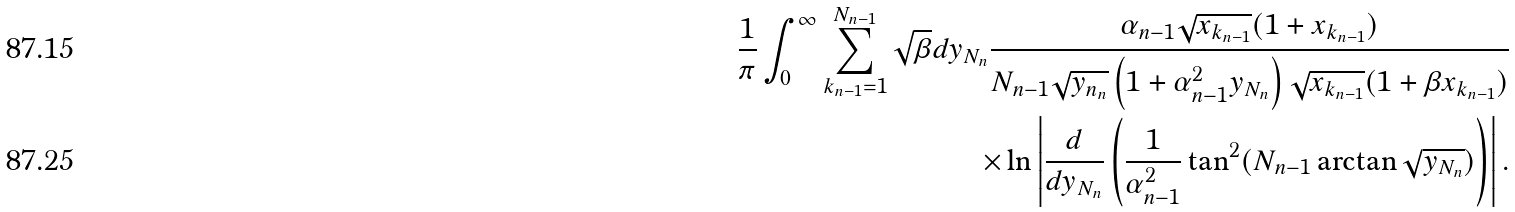<formula> <loc_0><loc_0><loc_500><loc_500>\frac { 1 } { \pi } \int _ { 0 } ^ { \infty } \sum _ { k _ { n - 1 } = 1 } ^ { N _ { n - 1 } } \sqrt { \beta } d y _ { N _ { n } } \frac { \alpha _ { n - 1 } \sqrt { x _ { k _ { n - 1 } } } ( 1 + x _ { k _ { n - 1 } } ) } { N _ { n - 1 } \sqrt { y _ { n _ { n } } } \left ( 1 + \alpha _ { n - 1 } ^ { 2 } y _ { N _ { n } } \right ) { \sqrt { x _ { k _ { n - 1 } } } } ( 1 + \beta x _ { k _ { n - 1 } } ) } \\ \times \ln \left | \frac { d } { d y _ { N _ { n } } } \left ( \frac { 1 } { \alpha _ { n - 1 } ^ { 2 } } \tan ^ { 2 } ( N _ { n - 1 } \arctan \sqrt { y _ { N _ { n } } } ) \right ) \right | .</formula> 